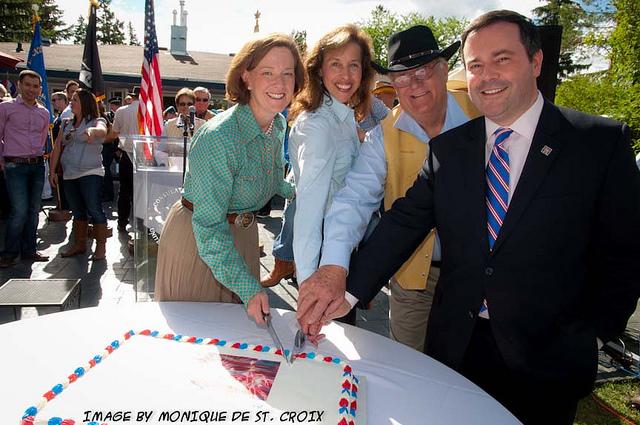How many people look like they're cutting the cake?
Quick response, please. 4. What color is the man's tie?
Answer briefly. Blue and pink. What country flag is in the picture?
Concise answer only. Usa. 